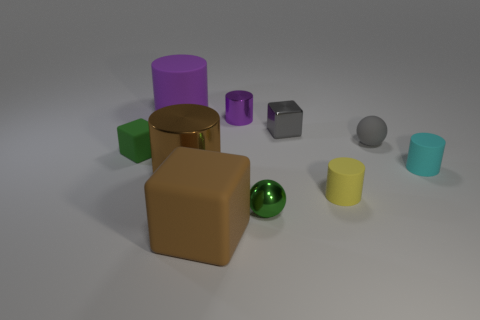Subtract all brown blocks. How many purple cylinders are left? 2 Subtract all gray shiny blocks. How many blocks are left? 2 Subtract all yellow cylinders. How many cylinders are left? 4 Subtract all spheres. How many objects are left? 8 Subtract all purple blocks. Subtract all red cylinders. How many blocks are left? 3 Subtract all tiny gray shiny spheres. Subtract all yellow objects. How many objects are left? 9 Add 7 small gray metallic things. How many small gray metallic things are left? 8 Add 4 big purple cylinders. How many big purple cylinders exist? 5 Subtract 0 cyan spheres. How many objects are left? 10 